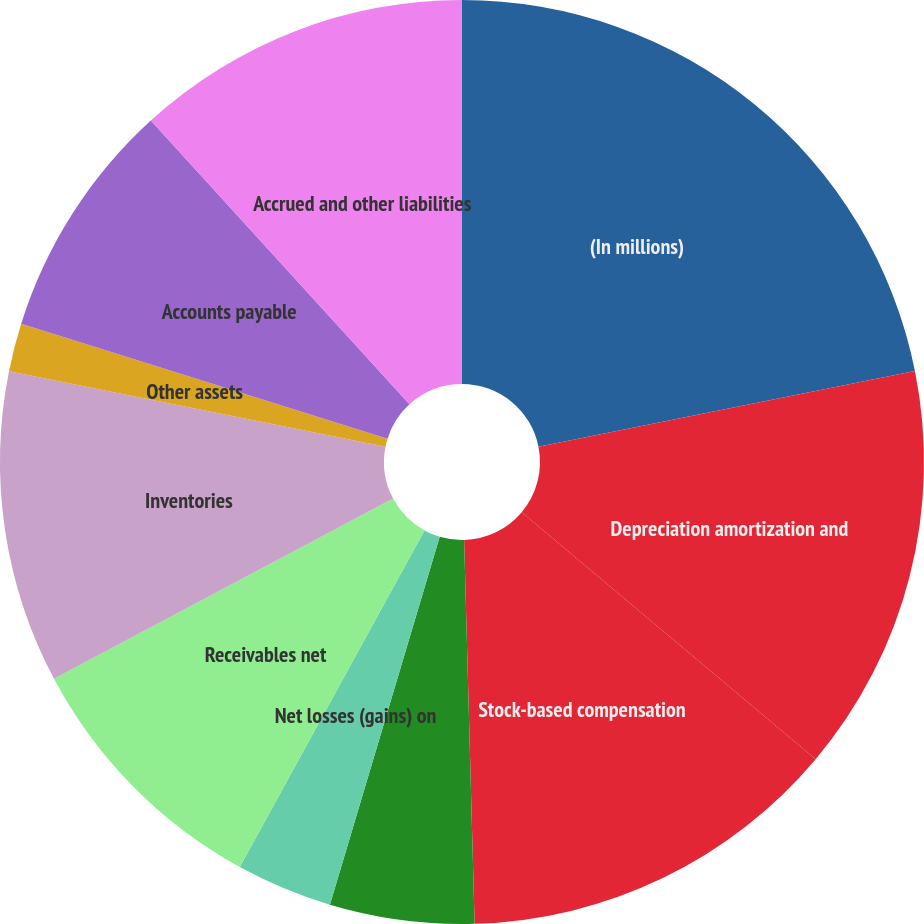Convert chart to OTSL. <chart><loc_0><loc_0><loc_500><loc_500><pie_chart><fcel>(In millions)<fcel>Depreciation amortization and<fcel>Stock-based compensation<fcel>Other non-cash restructuring<fcel>Net losses (gains) on<fcel>Receivables net<fcel>Inventories<fcel>Other assets<fcel>Accounts payable<fcel>Accrued and other liabilities<nl><fcel>21.84%<fcel>14.28%<fcel>13.44%<fcel>5.05%<fcel>3.37%<fcel>9.24%<fcel>10.92%<fcel>1.69%<fcel>8.4%<fcel>11.76%<nl></chart> 